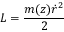Convert formula to latex. <formula><loc_0><loc_0><loc_500><loc_500>L = \frac { m ( z ) \dot { r } ^ { 2 } } { 2 }</formula> 